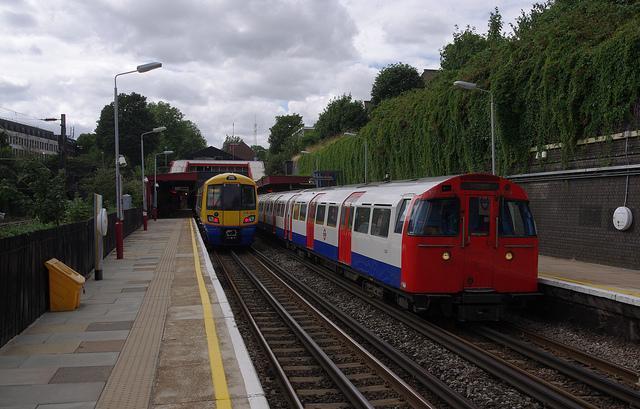How many trains are in this Picture?
Give a very brief answer. 2. How many trains are in the picture?
Give a very brief answer. 2. 